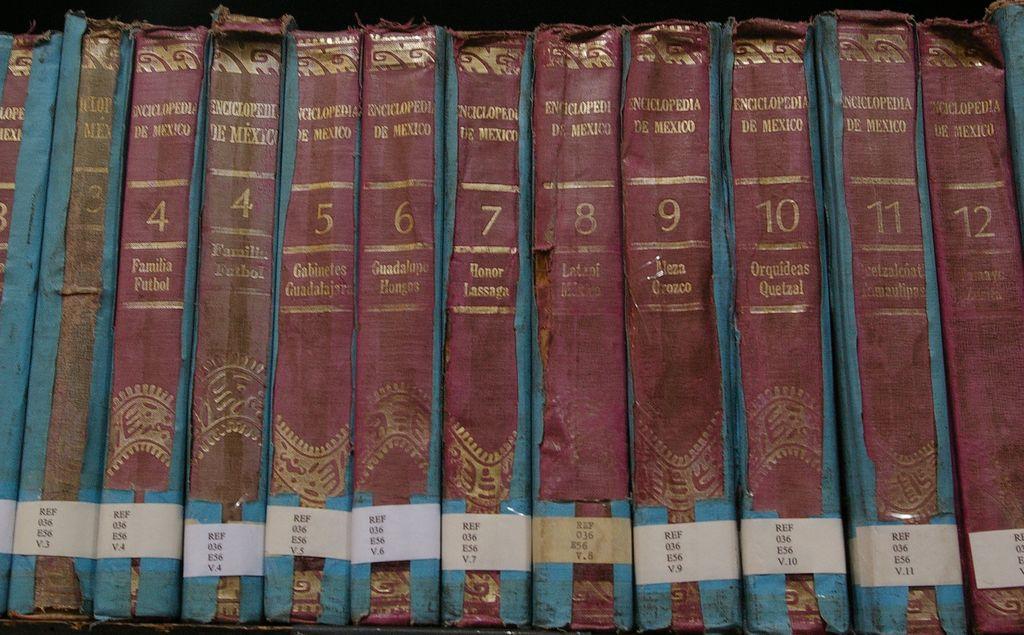What is the name of this series of books?
Ensure brevity in your answer.  Encyclopedia de mexico. What is the highest vol. shown in these books?
Your answer should be very brief. 12. 